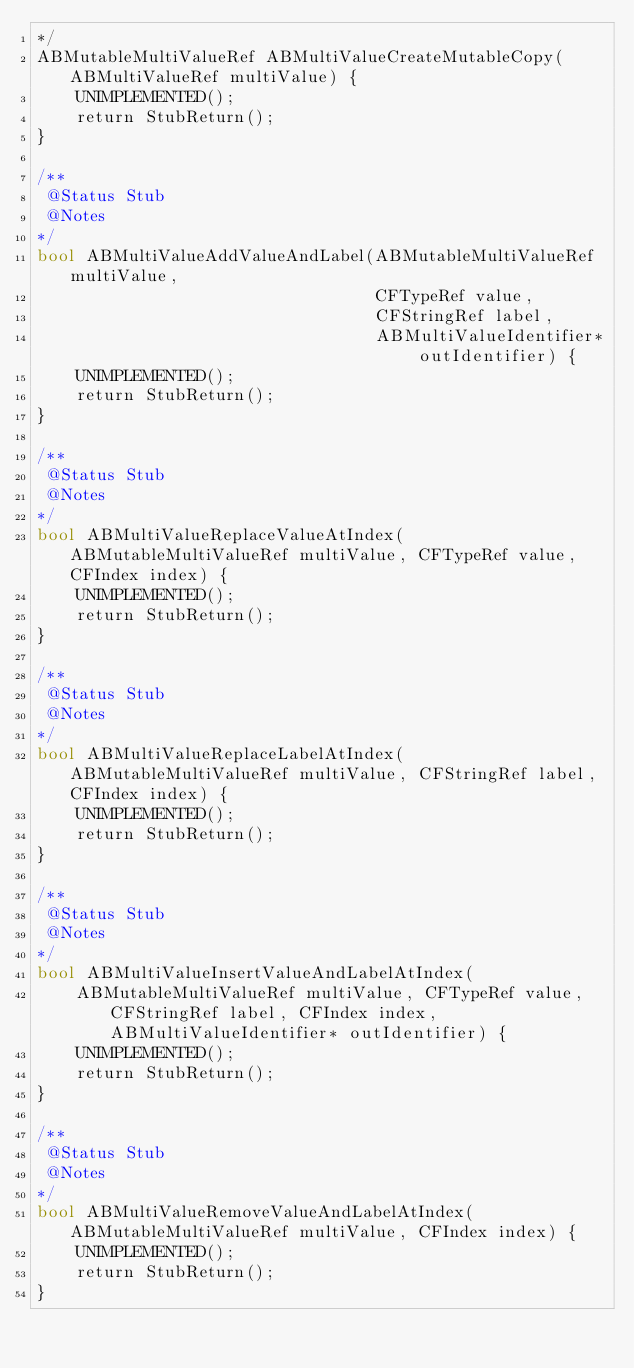Convert code to text. <code><loc_0><loc_0><loc_500><loc_500><_ObjectiveC_>*/
ABMutableMultiValueRef ABMultiValueCreateMutableCopy(ABMultiValueRef multiValue) {
    UNIMPLEMENTED();
    return StubReturn();
}

/**
 @Status Stub
 @Notes
*/
bool ABMultiValueAddValueAndLabel(ABMutableMultiValueRef multiValue,
                                  CFTypeRef value,
                                  CFStringRef label,
                                  ABMultiValueIdentifier* outIdentifier) {
    UNIMPLEMENTED();
    return StubReturn();
}

/**
 @Status Stub
 @Notes
*/
bool ABMultiValueReplaceValueAtIndex(ABMutableMultiValueRef multiValue, CFTypeRef value, CFIndex index) {
    UNIMPLEMENTED();
    return StubReturn();
}

/**
 @Status Stub
 @Notes
*/
bool ABMultiValueReplaceLabelAtIndex(ABMutableMultiValueRef multiValue, CFStringRef label, CFIndex index) {
    UNIMPLEMENTED();
    return StubReturn();
}

/**
 @Status Stub
 @Notes
*/
bool ABMultiValueInsertValueAndLabelAtIndex(
    ABMutableMultiValueRef multiValue, CFTypeRef value, CFStringRef label, CFIndex index, ABMultiValueIdentifier* outIdentifier) {
    UNIMPLEMENTED();
    return StubReturn();
}

/**
 @Status Stub
 @Notes
*/
bool ABMultiValueRemoveValueAndLabelAtIndex(ABMutableMultiValueRef multiValue, CFIndex index) {
    UNIMPLEMENTED();
    return StubReturn();
}
</code> 